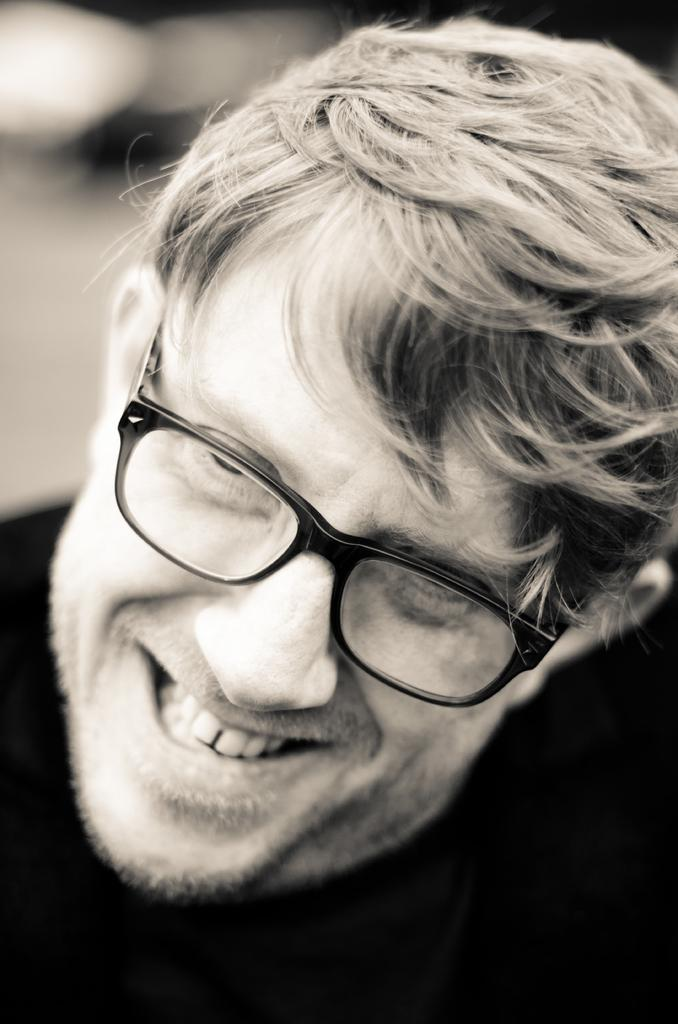What is the main subject of the image? There is a person in the image. What is the person's facial expression? The person is smiling. Can you describe the background of the image? The background of the image is blurry. How many quarters can be seen in the image? There are no quarters present in the image. What stage of development is the baseball at in the image? There is no baseball present in the image. 